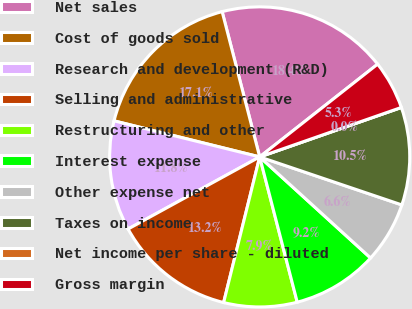Convert chart to OTSL. <chart><loc_0><loc_0><loc_500><loc_500><pie_chart><fcel>Net sales<fcel>Cost of goods sold<fcel>Research and development (R&D)<fcel>Selling and administrative<fcel>Restructuring and other<fcel>Interest expense<fcel>Other expense net<fcel>Taxes on income<fcel>Net income per share - diluted<fcel>Gross margin<nl><fcel>18.42%<fcel>17.11%<fcel>11.84%<fcel>13.16%<fcel>7.89%<fcel>9.21%<fcel>6.58%<fcel>10.53%<fcel>0.0%<fcel>5.26%<nl></chart> 